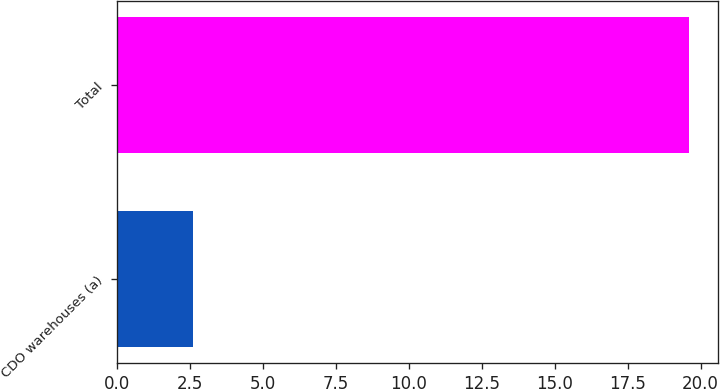Convert chart. <chart><loc_0><loc_0><loc_500><loc_500><bar_chart><fcel>CDO warehouses (a)<fcel>Total<nl><fcel>2.6<fcel>19.6<nl></chart> 